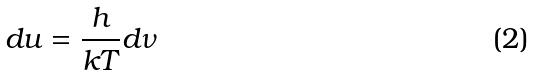<formula> <loc_0><loc_0><loc_500><loc_500>d u = \frac { h } { k T } d \nu</formula> 